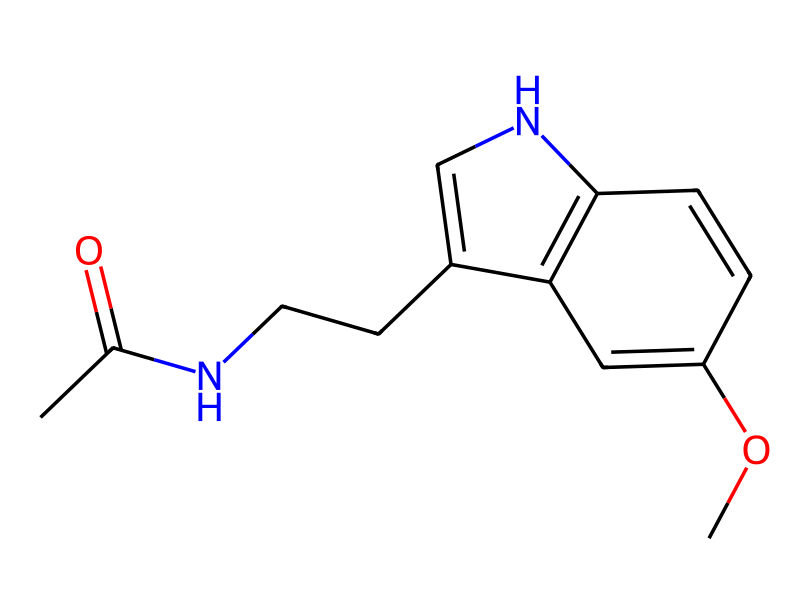What is the molecular formula of this compound? To determine the molecular formula, we need to count the atoms of each element present in the SMILES representation. By analyzing, we find: C= 12, H= 15, N= 2, O= 2, resulting in the molecular formula C12H15N2O2.
Answer: C12H15N2O2 How many rings are present in the structure? By examining the SMILES and identifying cyclic structures, we observe there is one ring (C1=CNc2c1). Therefore, the count is one.
Answer: 1 What functional groups are observed in this compound? Looking at the chemical structure, we can identify the acetyl (CC(=O)) and methoxy (OC) groups, which serve as the key functional groups.
Answer: acetyl and methoxy Is this compound an indole derivative? The SMILES structure features a nitrogen-containing side fused with a benzene ring, indicative of an indole structure, thus confirming it's a derivative.
Answer: yes What is the primary biological role of this compound? Melatonin's primary biological role is the regulation of sleep-wake cycles, as indicated by its well-established function in biological systems.
Answer: sleep regulation Does this compound contain any nitrogen atoms? Upon evaluating the SMILES representation, there are two nitrogen atoms clearly indicated in the structure, confirming their presence.
Answer: yes What is the significance of the acetyl group in this compound? The acetyl group is essential for the biosynthesis and functional role of melatonin, contributing to its hydrophobic nature and biological activity related to sleep.
Answer: hydrophobic nature 